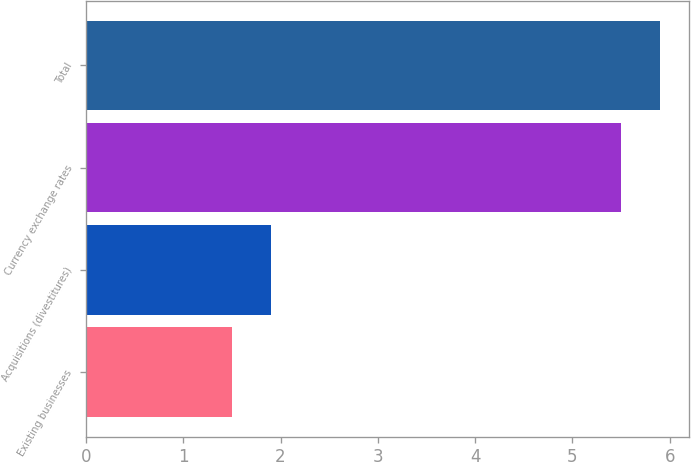Convert chart to OTSL. <chart><loc_0><loc_0><loc_500><loc_500><bar_chart><fcel>Existing businesses<fcel>Acquisitions (divestitures)<fcel>Currency exchange rates<fcel>Total<nl><fcel>1.5<fcel>1.9<fcel>5.5<fcel>5.9<nl></chart> 